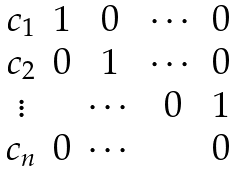<formula> <loc_0><loc_0><loc_500><loc_500>\begin{matrix} c _ { 1 } & 1 & 0 & \cdots & 0 \\ c _ { 2 } & 0 & 1 & \cdots & 0 \\ \vdots & & \cdots & 0 & 1 \\ c _ { n } & 0 & \cdots & & 0 \end{matrix}</formula> 